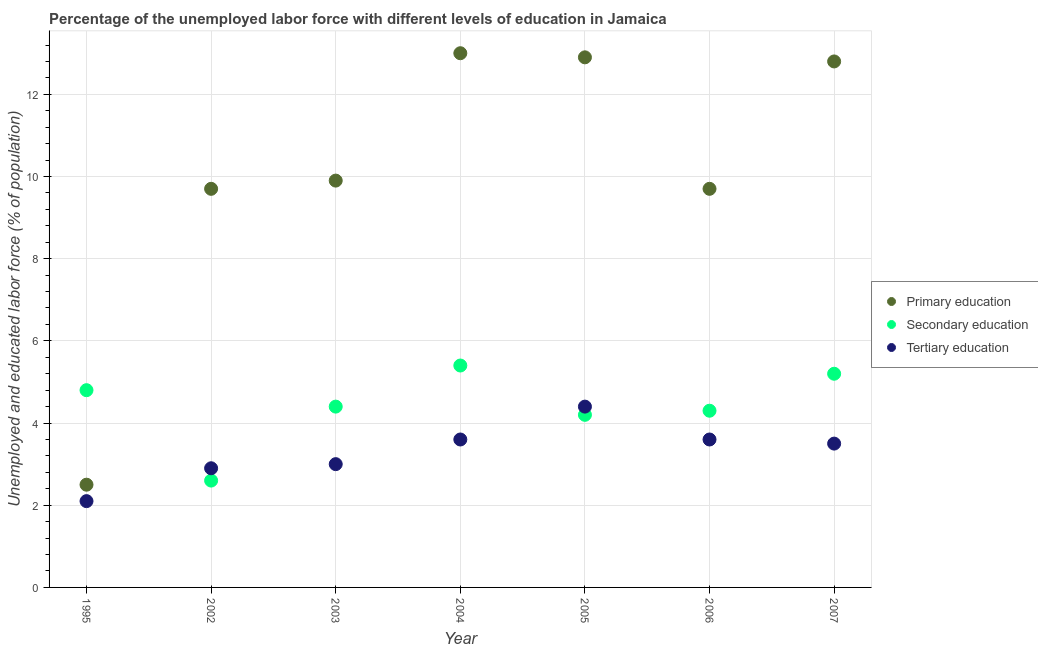What is the percentage of labor force who received secondary education in 2005?
Your response must be concise. 4.2. Across all years, what is the maximum percentage of labor force who received primary education?
Offer a very short reply. 13. In which year was the percentage of labor force who received primary education maximum?
Provide a succinct answer. 2004. What is the total percentage of labor force who received tertiary education in the graph?
Provide a short and direct response. 23.1. What is the difference between the percentage of labor force who received secondary education in 2005 and that in 2007?
Offer a terse response. -1. What is the difference between the percentage of labor force who received primary education in 2002 and the percentage of labor force who received secondary education in 2004?
Your response must be concise. 4.3. What is the average percentage of labor force who received primary education per year?
Offer a terse response. 10.07. In the year 2006, what is the difference between the percentage of labor force who received tertiary education and percentage of labor force who received primary education?
Your answer should be compact. -6.1. In how many years, is the percentage of labor force who received primary education greater than 3.2 %?
Offer a terse response. 6. Is the percentage of labor force who received tertiary education in 1995 less than that in 2004?
Keep it short and to the point. Yes. What is the difference between the highest and the second highest percentage of labor force who received secondary education?
Offer a very short reply. 0.2. What is the difference between the highest and the lowest percentage of labor force who received secondary education?
Provide a short and direct response. 2.8. Is it the case that in every year, the sum of the percentage of labor force who received primary education and percentage of labor force who received secondary education is greater than the percentage of labor force who received tertiary education?
Ensure brevity in your answer.  Yes. Is the percentage of labor force who received secondary education strictly less than the percentage of labor force who received tertiary education over the years?
Make the answer very short. No. How many dotlines are there?
Give a very brief answer. 3. How many legend labels are there?
Your response must be concise. 3. How are the legend labels stacked?
Provide a succinct answer. Vertical. What is the title of the graph?
Provide a short and direct response. Percentage of the unemployed labor force with different levels of education in Jamaica. What is the label or title of the Y-axis?
Provide a short and direct response. Unemployed and educated labor force (% of population). What is the Unemployed and educated labor force (% of population) of Secondary education in 1995?
Your answer should be very brief. 4.8. What is the Unemployed and educated labor force (% of population) in Tertiary education in 1995?
Your response must be concise. 2.1. What is the Unemployed and educated labor force (% of population) of Primary education in 2002?
Provide a succinct answer. 9.7. What is the Unemployed and educated labor force (% of population) of Secondary education in 2002?
Offer a very short reply. 2.6. What is the Unemployed and educated labor force (% of population) of Tertiary education in 2002?
Provide a succinct answer. 2.9. What is the Unemployed and educated labor force (% of population) of Primary education in 2003?
Ensure brevity in your answer.  9.9. What is the Unemployed and educated labor force (% of population) in Secondary education in 2003?
Offer a terse response. 4.4. What is the Unemployed and educated labor force (% of population) of Secondary education in 2004?
Keep it short and to the point. 5.4. What is the Unemployed and educated labor force (% of population) of Tertiary education in 2004?
Make the answer very short. 3.6. What is the Unemployed and educated labor force (% of population) of Primary education in 2005?
Make the answer very short. 12.9. What is the Unemployed and educated labor force (% of population) of Secondary education in 2005?
Offer a terse response. 4.2. What is the Unemployed and educated labor force (% of population) of Tertiary education in 2005?
Your answer should be compact. 4.4. What is the Unemployed and educated labor force (% of population) of Primary education in 2006?
Your answer should be compact. 9.7. What is the Unemployed and educated labor force (% of population) of Secondary education in 2006?
Keep it short and to the point. 4.3. What is the Unemployed and educated labor force (% of population) in Tertiary education in 2006?
Keep it short and to the point. 3.6. What is the Unemployed and educated labor force (% of population) of Primary education in 2007?
Make the answer very short. 12.8. What is the Unemployed and educated labor force (% of population) in Secondary education in 2007?
Ensure brevity in your answer.  5.2. What is the Unemployed and educated labor force (% of population) of Tertiary education in 2007?
Give a very brief answer. 3.5. Across all years, what is the maximum Unemployed and educated labor force (% of population) of Secondary education?
Give a very brief answer. 5.4. Across all years, what is the maximum Unemployed and educated labor force (% of population) in Tertiary education?
Provide a succinct answer. 4.4. Across all years, what is the minimum Unemployed and educated labor force (% of population) in Primary education?
Offer a terse response. 2.5. Across all years, what is the minimum Unemployed and educated labor force (% of population) in Secondary education?
Keep it short and to the point. 2.6. Across all years, what is the minimum Unemployed and educated labor force (% of population) in Tertiary education?
Your answer should be compact. 2.1. What is the total Unemployed and educated labor force (% of population) in Primary education in the graph?
Keep it short and to the point. 70.5. What is the total Unemployed and educated labor force (% of population) in Secondary education in the graph?
Provide a succinct answer. 30.9. What is the total Unemployed and educated labor force (% of population) of Tertiary education in the graph?
Ensure brevity in your answer.  23.1. What is the difference between the Unemployed and educated labor force (% of population) of Secondary education in 1995 and that in 2002?
Make the answer very short. 2.2. What is the difference between the Unemployed and educated labor force (% of population) of Tertiary education in 1995 and that in 2002?
Your response must be concise. -0.8. What is the difference between the Unemployed and educated labor force (% of population) in Secondary education in 1995 and that in 2003?
Offer a very short reply. 0.4. What is the difference between the Unemployed and educated labor force (% of population) of Tertiary education in 1995 and that in 2003?
Offer a terse response. -0.9. What is the difference between the Unemployed and educated labor force (% of population) in Primary education in 1995 and that in 2004?
Provide a succinct answer. -10.5. What is the difference between the Unemployed and educated labor force (% of population) of Tertiary education in 1995 and that in 2004?
Make the answer very short. -1.5. What is the difference between the Unemployed and educated labor force (% of population) in Secondary education in 1995 and that in 2005?
Make the answer very short. 0.6. What is the difference between the Unemployed and educated labor force (% of population) of Tertiary education in 1995 and that in 2005?
Provide a succinct answer. -2.3. What is the difference between the Unemployed and educated labor force (% of population) of Primary education in 1995 and that in 2006?
Provide a short and direct response. -7.2. What is the difference between the Unemployed and educated labor force (% of population) in Tertiary education in 1995 and that in 2006?
Provide a succinct answer. -1.5. What is the difference between the Unemployed and educated labor force (% of population) in Primary education in 1995 and that in 2007?
Provide a short and direct response. -10.3. What is the difference between the Unemployed and educated labor force (% of population) of Tertiary education in 1995 and that in 2007?
Provide a short and direct response. -1.4. What is the difference between the Unemployed and educated labor force (% of population) of Secondary education in 2002 and that in 2003?
Give a very brief answer. -1.8. What is the difference between the Unemployed and educated labor force (% of population) of Primary education in 2002 and that in 2004?
Offer a terse response. -3.3. What is the difference between the Unemployed and educated labor force (% of population) of Tertiary education in 2002 and that in 2004?
Offer a very short reply. -0.7. What is the difference between the Unemployed and educated labor force (% of population) in Primary education in 2002 and that in 2005?
Give a very brief answer. -3.2. What is the difference between the Unemployed and educated labor force (% of population) of Tertiary education in 2002 and that in 2005?
Ensure brevity in your answer.  -1.5. What is the difference between the Unemployed and educated labor force (% of population) of Primary education in 2002 and that in 2006?
Offer a very short reply. 0. What is the difference between the Unemployed and educated labor force (% of population) of Secondary education in 2002 and that in 2006?
Your response must be concise. -1.7. What is the difference between the Unemployed and educated labor force (% of population) in Tertiary education in 2002 and that in 2006?
Provide a succinct answer. -0.7. What is the difference between the Unemployed and educated labor force (% of population) of Primary education in 2002 and that in 2007?
Offer a very short reply. -3.1. What is the difference between the Unemployed and educated labor force (% of population) in Tertiary education in 2002 and that in 2007?
Provide a succinct answer. -0.6. What is the difference between the Unemployed and educated labor force (% of population) of Tertiary education in 2003 and that in 2004?
Provide a succinct answer. -0.6. What is the difference between the Unemployed and educated labor force (% of population) of Primary education in 2003 and that in 2005?
Your answer should be compact. -3. What is the difference between the Unemployed and educated labor force (% of population) in Secondary education in 2003 and that in 2005?
Provide a succinct answer. 0.2. What is the difference between the Unemployed and educated labor force (% of population) in Tertiary education in 2003 and that in 2005?
Your answer should be compact. -1.4. What is the difference between the Unemployed and educated labor force (% of population) of Secondary education in 2003 and that in 2006?
Ensure brevity in your answer.  0.1. What is the difference between the Unemployed and educated labor force (% of population) in Primary education in 2003 and that in 2007?
Your response must be concise. -2.9. What is the difference between the Unemployed and educated labor force (% of population) of Secondary education in 2003 and that in 2007?
Provide a short and direct response. -0.8. What is the difference between the Unemployed and educated labor force (% of population) of Tertiary education in 2003 and that in 2007?
Your response must be concise. -0.5. What is the difference between the Unemployed and educated labor force (% of population) in Secondary education in 2004 and that in 2005?
Give a very brief answer. 1.2. What is the difference between the Unemployed and educated labor force (% of population) in Primary education in 2004 and that in 2006?
Your answer should be very brief. 3.3. What is the difference between the Unemployed and educated labor force (% of population) of Secondary education in 2004 and that in 2006?
Ensure brevity in your answer.  1.1. What is the difference between the Unemployed and educated labor force (% of population) of Primary education in 2005 and that in 2006?
Your answer should be very brief. 3.2. What is the difference between the Unemployed and educated labor force (% of population) in Secondary education in 2005 and that in 2006?
Your answer should be compact. -0.1. What is the difference between the Unemployed and educated labor force (% of population) of Primary education in 2005 and that in 2007?
Offer a very short reply. 0.1. What is the difference between the Unemployed and educated labor force (% of population) of Primary education in 2006 and that in 2007?
Provide a succinct answer. -3.1. What is the difference between the Unemployed and educated labor force (% of population) in Tertiary education in 2006 and that in 2007?
Give a very brief answer. 0.1. What is the difference between the Unemployed and educated labor force (% of population) in Primary education in 1995 and the Unemployed and educated labor force (% of population) in Tertiary education in 2002?
Give a very brief answer. -0.4. What is the difference between the Unemployed and educated labor force (% of population) of Secondary education in 1995 and the Unemployed and educated labor force (% of population) of Tertiary education in 2004?
Offer a terse response. 1.2. What is the difference between the Unemployed and educated labor force (% of population) of Primary education in 1995 and the Unemployed and educated labor force (% of population) of Tertiary education in 2005?
Offer a terse response. -1.9. What is the difference between the Unemployed and educated labor force (% of population) of Primary education in 1995 and the Unemployed and educated labor force (% of population) of Secondary education in 2006?
Offer a very short reply. -1.8. What is the difference between the Unemployed and educated labor force (% of population) of Primary education in 1995 and the Unemployed and educated labor force (% of population) of Tertiary education in 2006?
Your answer should be very brief. -1.1. What is the difference between the Unemployed and educated labor force (% of population) of Secondary education in 1995 and the Unemployed and educated labor force (% of population) of Tertiary education in 2006?
Provide a short and direct response. 1.2. What is the difference between the Unemployed and educated labor force (% of population) in Primary education in 1995 and the Unemployed and educated labor force (% of population) in Secondary education in 2007?
Ensure brevity in your answer.  -2.7. What is the difference between the Unemployed and educated labor force (% of population) of Primary education in 1995 and the Unemployed and educated labor force (% of population) of Tertiary education in 2007?
Give a very brief answer. -1. What is the difference between the Unemployed and educated labor force (% of population) of Primary education in 2002 and the Unemployed and educated labor force (% of population) of Tertiary education in 2003?
Make the answer very short. 6.7. What is the difference between the Unemployed and educated labor force (% of population) of Primary education in 2002 and the Unemployed and educated labor force (% of population) of Secondary education in 2004?
Give a very brief answer. 4.3. What is the difference between the Unemployed and educated labor force (% of population) of Secondary education in 2002 and the Unemployed and educated labor force (% of population) of Tertiary education in 2004?
Your answer should be compact. -1. What is the difference between the Unemployed and educated labor force (% of population) in Primary education in 2002 and the Unemployed and educated labor force (% of population) in Tertiary education in 2006?
Make the answer very short. 6.1. What is the difference between the Unemployed and educated labor force (% of population) of Primary education in 2002 and the Unemployed and educated labor force (% of population) of Secondary education in 2007?
Your answer should be compact. 4.5. What is the difference between the Unemployed and educated labor force (% of population) of Secondary education in 2003 and the Unemployed and educated labor force (% of population) of Tertiary education in 2004?
Keep it short and to the point. 0.8. What is the difference between the Unemployed and educated labor force (% of population) in Primary education in 2003 and the Unemployed and educated labor force (% of population) in Tertiary education in 2005?
Keep it short and to the point. 5.5. What is the difference between the Unemployed and educated labor force (% of population) of Secondary education in 2003 and the Unemployed and educated labor force (% of population) of Tertiary education in 2005?
Provide a succinct answer. 0. What is the difference between the Unemployed and educated labor force (% of population) of Primary education in 2003 and the Unemployed and educated labor force (% of population) of Secondary education in 2006?
Keep it short and to the point. 5.6. What is the difference between the Unemployed and educated labor force (% of population) of Secondary education in 2003 and the Unemployed and educated labor force (% of population) of Tertiary education in 2006?
Provide a short and direct response. 0.8. What is the difference between the Unemployed and educated labor force (% of population) in Primary education in 2003 and the Unemployed and educated labor force (% of population) in Tertiary education in 2007?
Give a very brief answer. 6.4. What is the difference between the Unemployed and educated labor force (% of population) in Secondary education in 2003 and the Unemployed and educated labor force (% of population) in Tertiary education in 2007?
Provide a succinct answer. 0.9. What is the difference between the Unemployed and educated labor force (% of population) of Primary education in 2004 and the Unemployed and educated labor force (% of population) of Tertiary education in 2005?
Keep it short and to the point. 8.6. What is the difference between the Unemployed and educated labor force (% of population) in Primary education in 2004 and the Unemployed and educated labor force (% of population) in Secondary education in 2006?
Make the answer very short. 8.7. What is the difference between the Unemployed and educated labor force (% of population) in Secondary education in 2004 and the Unemployed and educated labor force (% of population) in Tertiary education in 2006?
Your response must be concise. 1.8. What is the difference between the Unemployed and educated labor force (% of population) of Primary education in 2005 and the Unemployed and educated labor force (% of population) of Secondary education in 2006?
Your answer should be very brief. 8.6. What is the difference between the Unemployed and educated labor force (% of population) of Primary education in 2005 and the Unemployed and educated labor force (% of population) of Secondary education in 2007?
Offer a very short reply. 7.7. What is the difference between the Unemployed and educated labor force (% of population) in Primary education in 2005 and the Unemployed and educated labor force (% of population) in Tertiary education in 2007?
Ensure brevity in your answer.  9.4. What is the difference between the Unemployed and educated labor force (% of population) in Primary education in 2006 and the Unemployed and educated labor force (% of population) in Tertiary education in 2007?
Ensure brevity in your answer.  6.2. What is the average Unemployed and educated labor force (% of population) in Primary education per year?
Your answer should be compact. 10.07. What is the average Unemployed and educated labor force (% of population) of Secondary education per year?
Your answer should be compact. 4.41. In the year 1995, what is the difference between the Unemployed and educated labor force (% of population) of Primary education and Unemployed and educated labor force (% of population) of Secondary education?
Make the answer very short. -2.3. In the year 1995, what is the difference between the Unemployed and educated labor force (% of population) in Primary education and Unemployed and educated labor force (% of population) in Tertiary education?
Offer a terse response. 0.4. In the year 2002, what is the difference between the Unemployed and educated labor force (% of population) in Primary education and Unemployed and educated labor force (% of population) in Secondary education?
Your response must be concise. 7.1. In the year 2003, what is the difference between the Unemployed and educated labor force (% of population) in Primary education and Unemployed and educated labor force (% of population) in Secondary education?
Your response must be concise. 5.5. In the year 2003, what is the difference between the Unemployed and educated labor force (% of population) in Primary education and Unemployed and educated labor force (% of population) in Tertiary education?
Make the answer very short. 6.9. In the year 2006, what is the difference between the Unemployed and educated labor force (% of population) in Primary education and Unemployed and educated labor force (% of population) in Secondary education?
Your answer should be compact. 5.4. In the year 2006, what is the difference between the Unemployed and educated labor force (% of population) in Secondary education and Unemployed and educated labor force (% of population) in Tertiary education?
Offer a very short reply. 0.7. What is the ratio of the Unemployed and educated labor force (% of population) of Primary education in 1995 to that in 2002?
Your response must be concise. 0.26. What is the ratio of the Unemployed and educated labor force (% of population) in Secondary education in 1995 to that in 2002?
Provide a short and direct response. 1.85. What is the ratio of the Unemployed and educated labor force (% of population) in Tertiary education in 1995 to that in 2002?
Give a very brief answer. 0.72. What is the ratio of the Unemployed and educated labor force (% of population) in Primary education in 1995 to that in 2003?
Your answer should be compact. 0.25. What is the ratio of the Unemployed and educated labor force (% of population) in Secondary education in 1995 to that in 2003?
Your answer should be very brief. 1.09. What is the ratio of the Unemployed and educated labor force (% of population) in Primary education in 1995 to that in 2004?
Provide a succinct answer. 0.19. What is the ratio of the Unemployed and educated labor force (% of population) in Secondary education in 1995 to that in 2004?
Provide a succinct answer. 0.89. What is the ratio of the Unemployed and educated labor force (% of population) in Tertiary education in 1995 to that in 2004?
Ensure brevity in your answer.  0.58. What is the ratio of the Unemployed and educated labor force (% of population) of Primary education in 1995 to that in 2005?
Provide a short and direct response. 0.19. What is the ratio of the Unemployed and educated labor force (% of population) of Secondary education in 1995 to that in 2005?
Offer a very short reply. 1.14. What is the ratio of the Unemployed and educated labor force (% of population) in Tertiary education in 1995 to that in 2005?
Provide a short and direct response. 0.48. What is the ratio of the Unemployed and educated labor force (% of population) of Primary education in 1995 to that in 2006?
Ensure brevity in your answer.  0.26. What is the ratio of the Unemployed and educated labor force (% of population) of Secondary education in 1995 to that in 2006?
Keep it short and to the point. 1.12. What is the ratio of the Unemployed and educated labor force (% of population) in Tertiary education in 1995 to that in 2006?
Give a very brief answer. 0.58. What is the ratio of the Unemployed and educated labor force (% of population) in Primary education in 1995 to that in 2007?
Your answer should be compact. 0.2. What is the ratio of the Unemployed and educated labor force (% of population) in Secondary education in 1995 to that in 2007?
Provide a succinct answer. 0.92. What is the ratio of the Unemployed and educated labor force (% of population) in Tertiary education in 1995 to that in 2007?
Make the answer very short. 0.6. What is the ratio of the Unemployed and educated labor force (% of population) of Primary education in 2002 to that in 2003?
Offer a very short reply. 0.98. What is the ratio of the Unemployed and educated labor force (% of population) of Secondary education in 2002 to that in 2003?
Keep it short and to the point. 0.59. What is the ratio of the Unemployed and educated labor force (% of population) of Tertiary education in 2002 to that in 2003?
Your answer should be compact. 0.97. What is the ratio of the Unemployed and educated labor force (% of population) of Primary education in 2002 to that in 2004?
Your response must be concise. 0.75. What is the ratio of the Unemployed and educated labor force (% of population) in Secondary education in 2002 to that in 2004?
Make the answer very short. 0.48. What is the ratio of the Unemployed and educated labor force (% of population) of Tertiary education in 2002 to that in 2004?
Keep it short and to the point. 0.81. What is the ratio of the Unemployed and educated labor force (% of population) of Primary education in 2002 to that in 2005?
Keep it short and to the point. 0.75. What is the ratio of the Unemployed and educated labor force (% of population) in Secondary education in 2002 to that in 2005?
Your response must be concise. 0.62. What is the ratio of the Unemployed and educated labor force (% of population) in Tertiary education in 2002 to that in 2005?
Make the answer very short. 0.66. What is the ratio of the Unemployed and educated labor force (% of population) in Secondary education in 2002 to that in 2006?
Your answer should be compact. 0.6. What is the ratio of the Unemployed and educated labor force (% of population) of Tertiary education in 2002 to that in 2006?
Offer a very short reply. 0.81. What is the ratio of the Unemployed and educated labor force (% of population) of Primary education in 2002 to that in 2007?
Provide a succinct answer. 0.76. What is the ratio of the Unemployed and educated labor force (% of population) in Secondary education in 2002 to that in 2007?
Offer a terse response. 0.5. What is the ratio of the Unemployed and educated labor force (% of population) of Tertiary education in 2002 to that in 2007?
Your response must be concise. 0.83. What is the ratio of the Unemployed and educated labor force (% of population) of Primary education in 2003 to that in 2004?
Give a very brief answer. 0.76. What is the ratio of the Unemployed and educated labor force (% of population) of Secondary education in 2003 to that in 2004?
Keep it short and to the point. 0.81. What is the ratio of the Unemployed and educated labor force (% of population) in Primary education in 2003 to that in 2005?
Your answer should be compact. 0.77. What is the ratio of the Unemployed and educated labor force (% of population) of Secondary education in 2003 to that in 2005?
Your answer should be very brief. 1.05. What is the ratio of the Unemployed and educated labor force (% of population) of Tertiary education in 2003 to that in 2005?
Make the answer very short. 0.68. What is the ratio of the Unemployed and educated labor force (% of population) of Primary education in 2003 to that in 2006?
Ensure brevity in your answer.  1.02. What is the ratio of the Unemployed and educated labor force (% of population) of Secondary education in 2003 to that in 2006?
Your response must be concise. 1.02. What is the ratio of the Unemployed and educated labor force (% of population) in Primary education in 2003 to that in 2007?
Provide a succinct answer. 0.77. What is the ratio of the Unemployed and educated labor force (% of population) of Secondary education in 2003 to that in 2007?
Your answer should be compact. 0.85. What is the ratio of the Unemployed and educated labor force (% of population) in Tertiary education in 2003 to that in 2007?
Your answer should be compact. 0.86. What is the ratio of the Unemployed and educated labor force (% of population) of Primary education in 2004 to that in 2005?
Offer a very short reply. 1.01. What is the ratio of the Unemployed and educated labor force (% of population) in Tertiary education in 2004 to that in 2005?
Offer a terse response. 0.82. What is the ratio of the Unemployed and educated labor force (% of population) of Primary education in 2004 to that in 2006?
Offer a very short reply. 1.34. What is the ratio of the Unemployed and educated labor force (% of population) of Secondary education in 2004 to that in 2006?
Offer a very short reply. 1.26. What is the ratio of the Unemployed and educated labor force (% of population) of Primary education in 2004 to that in 2007?
Your answer should be very brief. 1.02. What is the ratio of the Unemployed and educated labor force (% of population) of Tertiary education in 2004 to that in 2007?
Your answer should be compact. 1.03. What is the ratio of the Unemployed and educated labor force (% of population) in Primary education in 2005 to that in 2006?
Provide a succinct answer. 1.33. What is the ratio of the Unemployed and educated labor force (% of population) in Secondary education in 2005 to that in 2006?
Provide a short and direct response. 0.98. What is the ratio of the Unemployed and educated labor force (% of population) of Tertiary education in 2005 to that in 2006?
Your answer should be compact. 1.22. What is the ratio of the Unemployed and educated labor force (% of population) of Secondary education in 2005 to that in 2007?
Your response must be concise. 0.81. What is the ratio of the Unemployed and educated labor force (% of population) of Tertiary education in 2005 to that in 2007?
Make the answer very short. 1.26. What is the ratio of the Unemployed and educated labor force (% of population) in Primary education in 2006 to that in 2007?
Your answer should be compact. 0.76. What is the ratio of the Unemployed and educated labor force (% of population) in Secondary education in 2006 to that in 2007?
Keep it short and to the point. 0.83. What is the ratio of the Unemployed and educated labor force (% of population) in Tertiary education in 2006 to that in 2007?
Give a very brief answer. 1.03. What is the difference between the highest and the second highest Unemployed and educated labor force (% of population) of Primary education?
Offer a terse response. 0.1. What is the difference between the highest and the second highest Unemployed and educated labor force (% of population) of Secondary education?
Make the answer very short. 0.2. 